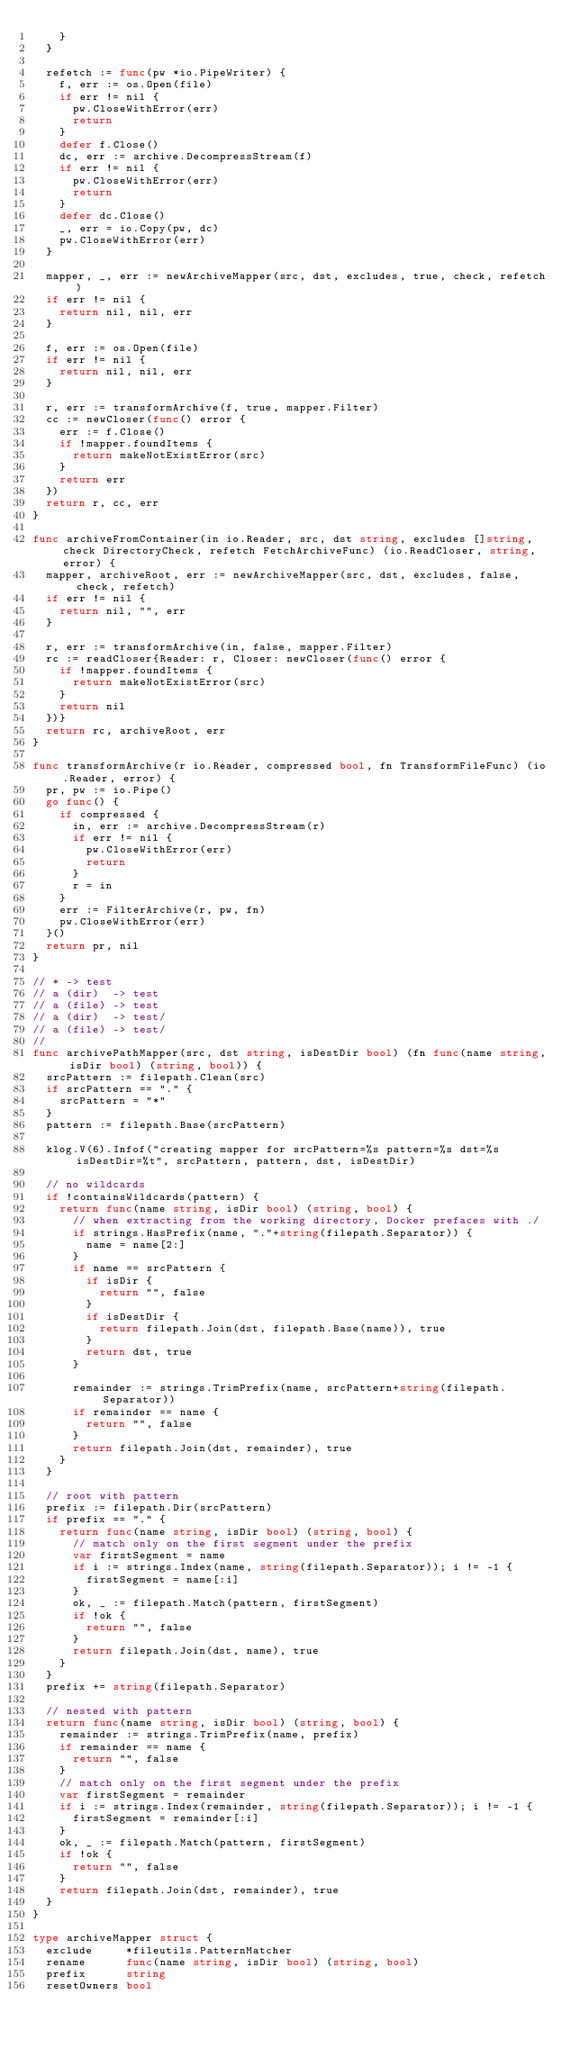Convert code to text. <code><loc_0><loc_0><loc_500><loc_500><_Go_>		}
	}

	refetch := func(pw *io.PipeWriter) {
		f, err := os.Open(file)
		if err != nil {
			pw.CloseWithError(err)
			return
		}
		defer f.Close()
		dc, err := archive.DecompressStream(f)
		if err != nil {
			pw.CloseWithError(err)
			return
		}
		defer dc.Close()
		_, err = io.Copy(pw, dc)
		pw.CloseWithError(err)
	}

	mapper, _, err := newArchiveMapper(src, dst, excludes, true, check, refetch)
	if err != nil {
		return nil, nil, err
	}

	f, err := os.Open(file)
	if err != nil {
		return nil, nil, err
	}

	r, err := transformArchive(f, true, mapper.Filter)
	cc := newCloser(func() error {
		err := f.Close()
		if !mapper.foundItems {
			return makeNotExistError(src)
		}
		return err
	})
	return r, cc, err
}

func archiveFromContainer(in io.Reader, src, dst string, excludes []string, check DirectoryCheck, refetch FetchArchiveFunc) (io.ReadCloser, string, error) {
	mapper, archiveRoot, err := newArchiveMapper(src, dst, excludes, false, check, refetch)
	if err != nil {
		return nil, "", err
	}

	r, err := transformArchive(in, false, mapper.Filter)
	rc := readCloser{Reader: r, Closer: newCloser(func() error {
		if !mapper.foundItems {
			return makeNotExistError(src)
		}
		return nil
	})}
	return rc, archiveRoot, err
}

func transformArchive(r io.Reader, compressed bool, fn TransformFileFunc) (io.Reader, error) {
	pr, pw := io.Pipe()
	go func() {
		if compressed {
			in, err := archive.DecompressStream(r)
			if err != nil {
				pw.CloseWithError(err)
				return
			}
			r = in
		}
		err := FilterArchive(r, pw, fn)
		pw.CloseWithError(err)
	}()
	return pr, nil
}

// * -> test
// a (dir)  -> test
// a (file) -> test
// a (dir)  -> test/
// a (file) -> test/
//
func archivePathMapper(src, dst string, isDestDir bool) (fn func(name string, isDir bool) (string, bool)) {
	srcPattern := filepath.Clean(src)
	if srcPattern == "." {
		srcPattern = "*"
	}
	pattern := filepath.Base(srcPattern)

	klog.V(6).Infof("creating mapper for srcPattern=%s pattern=%s dst=%s isDestDir=%t", srcPattern, pattern, dst, isDestDir)

	// no wildcards
	if !containsWildcards(pattern) {
		return func(name string, isDir bool) (string, bool) {
			// when extracting from the working directory, Docker prefaces with ./
			if strings.HasPrefix(name, "."+string(filepath.Separator)) {
				name = name[2:]
			}
			if name == srcPattern {
				if isDir {
					return "", false
				}
				if isDestDir {
					return filepath.Join(dst, filepath.Base(name)), true
				}
				return dst, true
			}

			remainder := strings.TrimPrefix(name, srcPattern+string(filepath.Separator))
			if remainder == name {
				return "", false
			}
			return filepath.Join(dst, remainder), true
		}
	}

	// root with pattern
	prefix := filepath.Dir(srcPattern)
	if prefix == "." {
		return func(name string, isDir bool) (string, bool) {
			// match only on the first segment under the prefix
			var firstSegment = name
			if i := strings.Index(name, string(filepath.Separator)); i != -1 {
				firstSegment = name[:i]
			}
			ok, _ := filepath.Match(pattern, firstSegment)
			if !ok {
				return "", false
			}
			return filepath.Join(dst, name), true
		}
	}
	prefix += string(filepath.Separator)

	// nested with pattern
	return func(name string, isDir bool) (string, bool) {
		remainder := strings.TrimPrefix(name, prefix)
		if remainder == name {
			return "", false
		}
		// match only on the first segment under the prefix
		var firstSegment = remainder
		if i := strings.Index(remainder, string(filepath.Separator)); i != -1 {
			firstSegment = remainder[:i]
		}
		ok, _ := filepath.Match(pattern, firstSegment)
		if !ok {
			return "", false
		}
		return filepath.Join(dst, remainder), true
	}
}

type archiveMapper struct {
	exclude     *fileutils.PatternMatcher
	rename      func(name string, isDir bool) (string, bool)
	prefix      string
	resetOwners bool</code> 